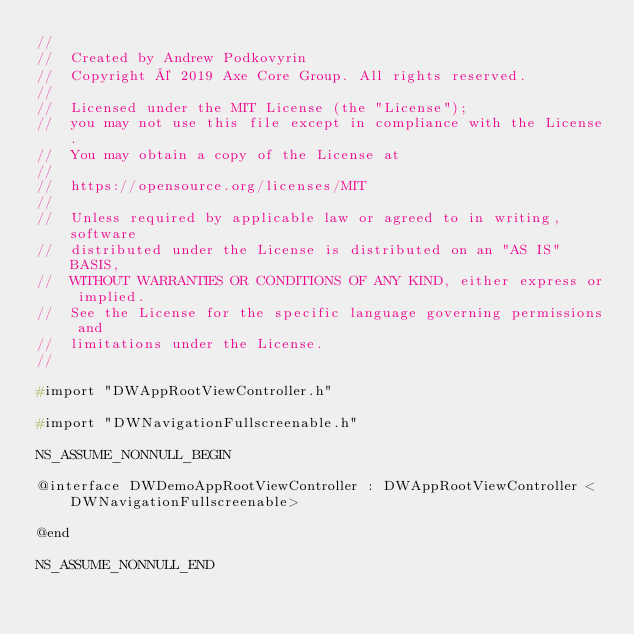Convert code to text. <code><loc_0><loc_0><loc_500><loc_500><_C_>//
//  Created by Andrew Podkovyrin
//  Copyright © 2019 Axe Core Group. All rights reserved.
//
//  Licensed under the MIT License (the "License");
//  you may not use this file except in compliance with the License.
//  You may obtain a copy of the License at
//
//  https://opensource.org/licenses/MIT
//
//  Unless required by applicable law or agreed to in writing, software
//  distributed under the License is distributed on an "AS IS" BASIS,
//  WITHOUT WARRANTIES OR CONDITIONS OF ANY KIND, either express or implied.
//  See the License for the specific language governing permissions and
//  limitations under the License.
//

#import "DWAppRootViewController.h"

#import "DWNavigationFullscreenable.h"

NS_ASSUME_NONNULL_BEGIN

@interface DWDemoAppRootViewController : DWAppRootViewController <DWNavigationFullscreenable>

@end

NS_ASSUME_NONNULL_END
</code> 